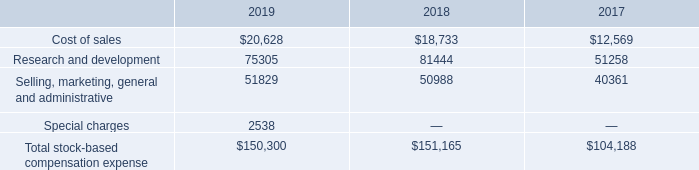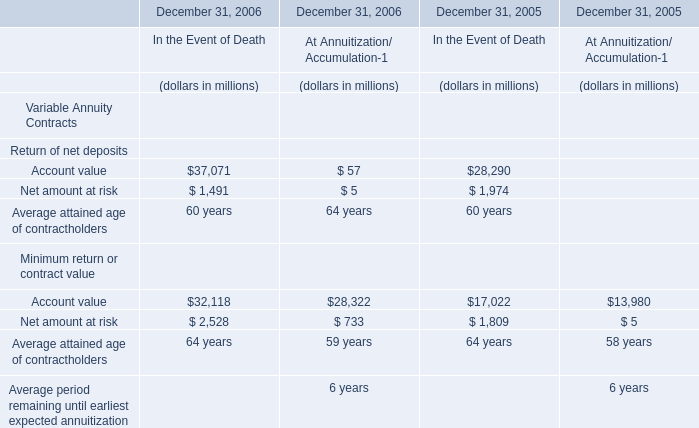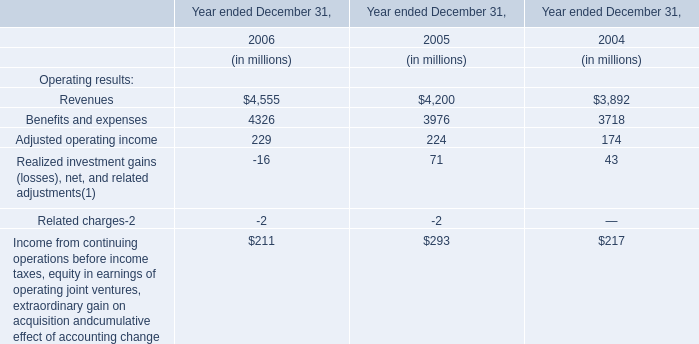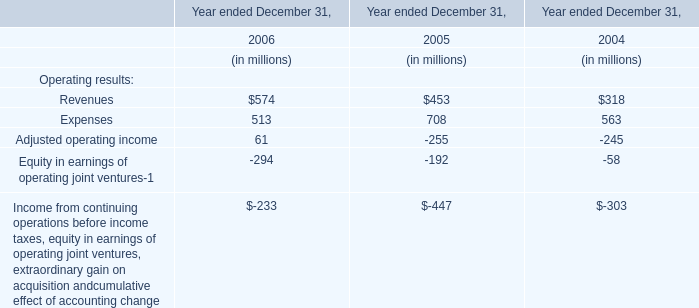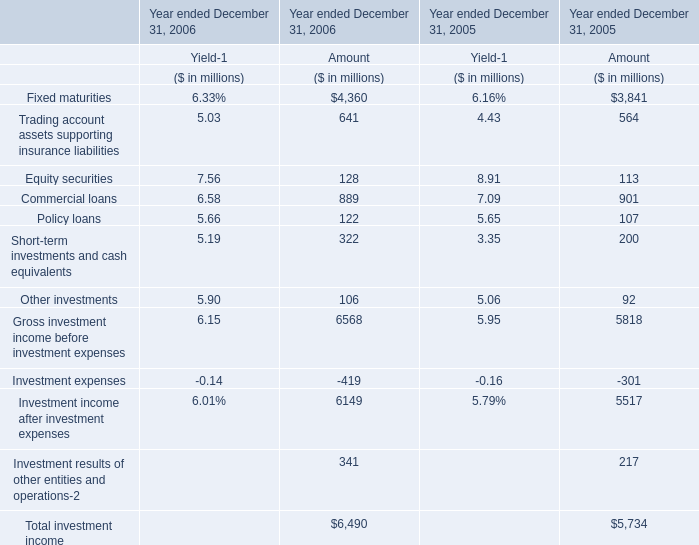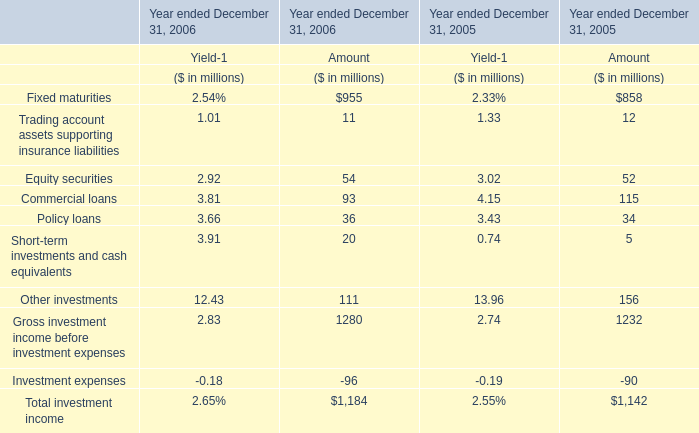what is the growth rate in the cost of sales in 2019? 
Computations: ((20628 - 18733) / 18733)
Answer: 0.10116. 